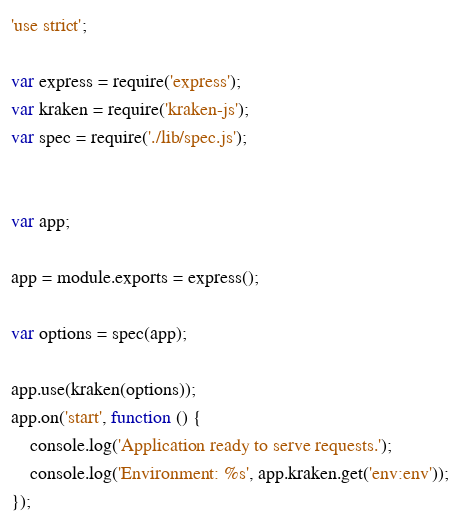<code> <loc_0><loc_0><loc_500><loc_500><_JavaScript_>'use strict';

var express = require('express');
var kraken = require('kraken-js');
var spec = require('./lib/spec.js');


var app;

app = module.exports = express();

var options = spec(app);

app.use(kraken(options));
app.on('start', function () {
    console.log('Application ready to serve requests.');
    console.log('Environment: %s', app.kraken.get('env:env'));
});
</code> 